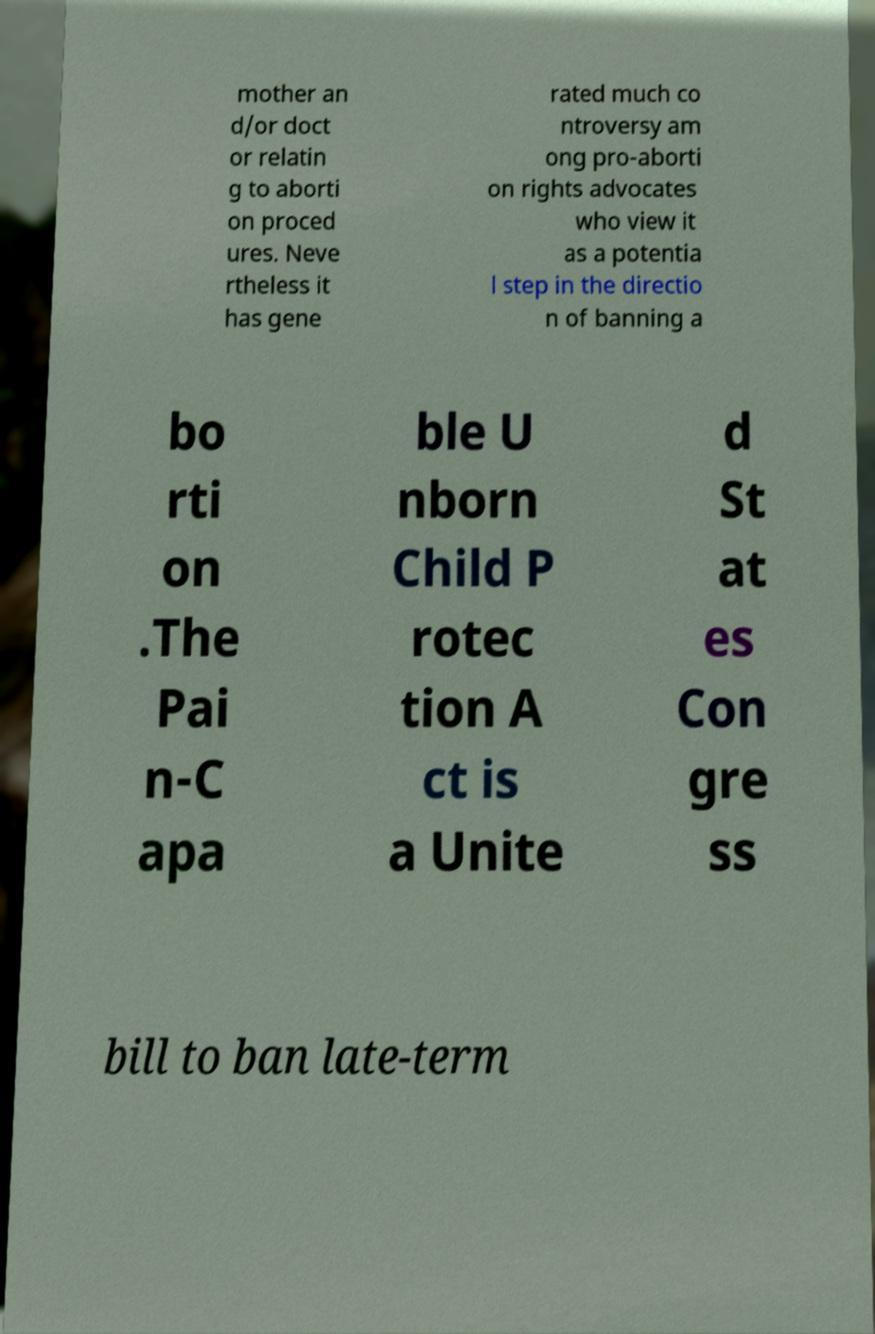I need the written content from this picture converted into text. Can you do that? mother an d/or doct or relatin g to aborti on proced ures. Neve rtheless it has gene rated much co ntroversy am ong pro-aborti on rights advocates who view it as a potentia l step in the directio n of banning a bo rti on .The Pai n-C apa ble U nborn Child P rotec tion A ct is a Unite d St at es Con gre ss bill to ban late-term 